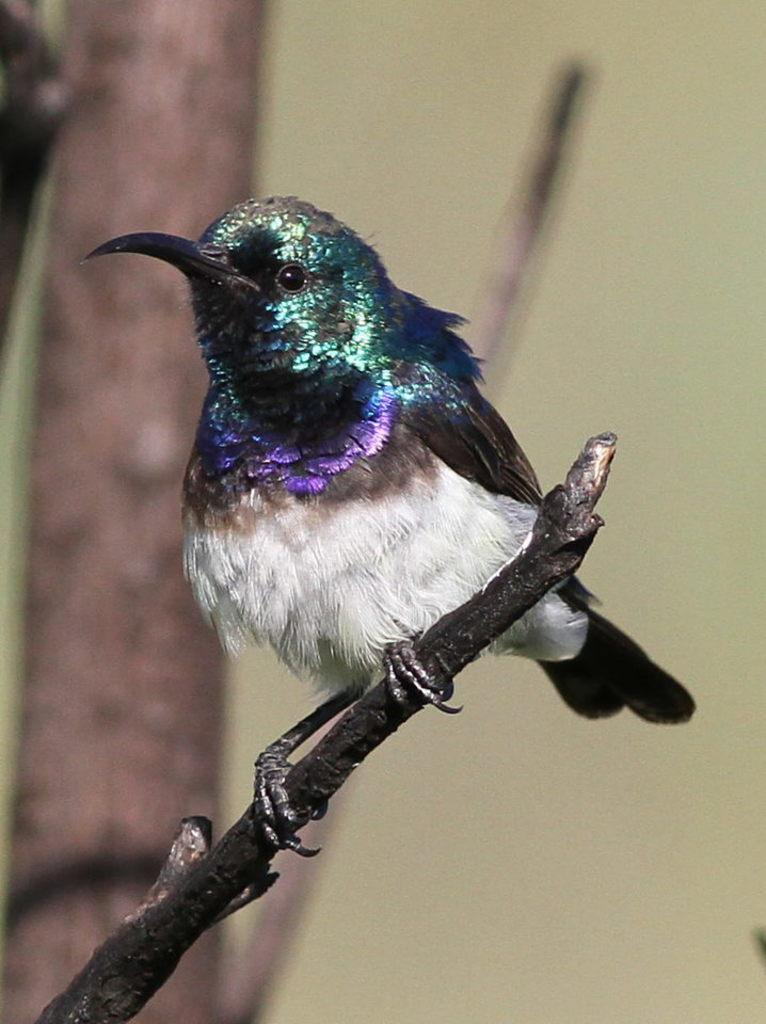What type of animal can be seen in the image? There is a bird in the image. Where is the bird located? The bird is on a branch. What colors can be seen on the bird? The bird has black, white, green, blue, and brown colors. How would you describe the background of the image? The background of the image has cream and brown colors. What type of polish is the bird using to maintain its feathers in the image? There is no indication in the image that the bird is using any polish to maintain its feathers. 